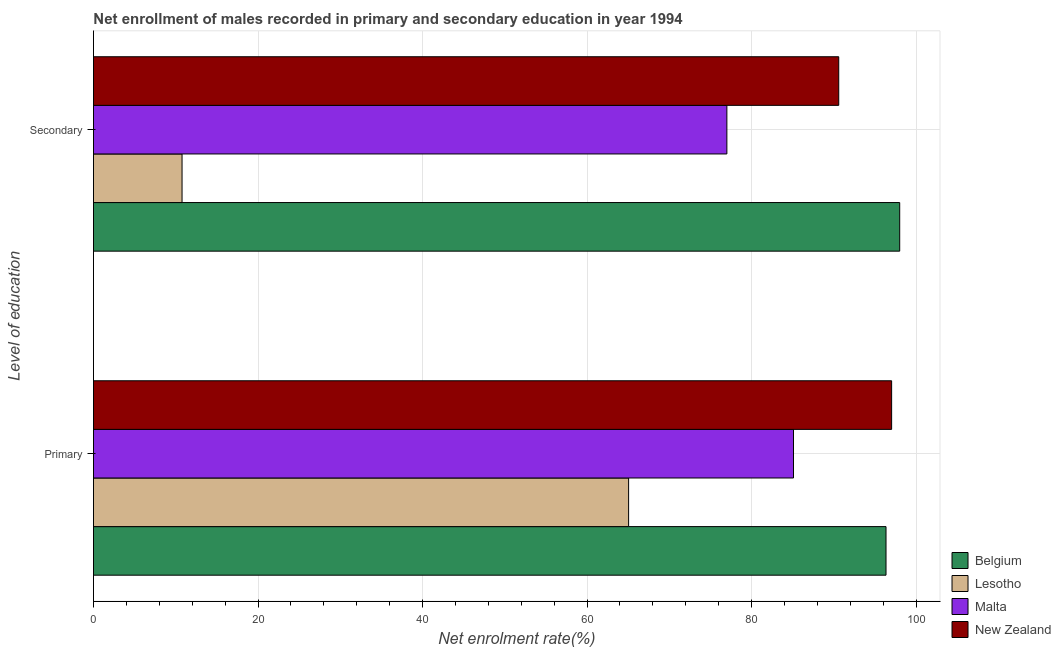How many groups of bars are there?
Offer a very short reply. 2. Are the number of bars on each tick of the Y-axis equal?
Offer a very short reply. Yes. How many bars are there on the 2nd tick from the top?
Your answer should be compact. 4. What is the label of the 1st group of bars from the top?
Ensure brevity in your answer.  Secondary. What is the enrollment rate in primary education in Belgium?
Make the answer very short. 96.34. Across all countries, what is the maximum enrollment rate in primary education?
Provide a short and direct response. 97.02. Across all countries, what is the minimum enrollment rate in primary education?
Provide a succinct answer. 65.05. In which country was the enrollment rate in primary education maximum?
Provide a succinct answer. New Zealand. In which country was the enrollment rate in secondary education minimum?
Your response must be concise. Lesotho. What is the total enrollment rate in primary education in the graph?
Keep it short and to the point. 343.49. What is the difference between the enrollment rate in primary education in Belgium and that in New Zealand?
Provide a succinct answer. -0.68. What is the difference between the enrollment rate in secondary education in Lesotho and the enrollment rate in primary education in Malta?
Provide a short and direct response. -74.32. What is the average enrollment rate in primary education per country?
Provide a succinct answer. 85.87. What is the difference between the enrollment rate in secondary education and enrollment rate in primary education in Belgium?
Provide a succinct answer. 1.66. What is the ratio of the enrollment rate in primary education in Lesotho to that in Malta?
Your answer should be very brief. 0.76. In how many countries, is the enrollment rate in primary education greater than the average enrollment rate in primary education taken over all countries?
Provide a short and direct response. 2. What does the 3rd bar from the top in Secondary represents?
Give a very brief answer. Lesotho. What does the 2nd bar from the bottom in Primary represents?
Your answer should be very brief. Lesotho. How many bars are there?
Offer a terse response. 8. Does the graph contain grids?
Provide a succinct answer. Yes. Where does the legend appear in the graph?
Provide a succinct answer. Bottom right. How are the legend labels stacked?
Provide a succinct answer. Vertical. What is the title of the graph?
Provide a succinct answer. Net enrollment of males recorded in primary and secondary education in year 1994. Does "Malta" appear as one of the legend labels in the graph?
Your answer should be compact. Yes. What is the label or title of the X-axis?
Your answer should be compact. Net enrolment rate(%). What is the label or title of the Y-axis?
Offer a terse response. Level of education. What is the Net enrolment rate(%) of Belgium in Primary?
Your response must be concise. 96.34. What is the Net enrolment rate(%) in Lesotho in Primary?
Your answer should be compact. 65.05. What is the Net enrolment rate(%) in Malta in Primary?
Ensure brevity in your answer.  85.09. What is the Net enrolment rate(%) in New Zealand in Primary?
Provide a short and direct response. 97.02. What is the Net enrolment rate(%) in Belgium in Secondary?
Provide a succinct answer. 98. What is the Net enrolment rate(%) in Lesotho in Secondary?
Give a very brief answer. 10.77. What is the Net enrolment rate(%) in Malta in Secondary?
Give a very brief answer. 76.99. What is the Net enrolment rate(%) of New Zealand in Secondary?
Your answer should be compact. 90.59. Across all Level of education, what is the maximum Net enrolment rate(%) of Belgium?
Ensure brevity in your answer.  98. Across all Level of education, what is the maximum Net enrolment rate(%) in Lesotho?
Your response must be concise. 65.05. Across all Level of education, what is the maximum Net enrolment rate(%) of Malta?
Your answer should be very brief. 85.09. Across all Level of education, what is the maximum Net enrolment rate(%) of New Zealand?
Give a very brief answer. 97.02. Across all Level of education, what is the minimum Net enrolment rate(%) in Belgium?
Offer a terse response. 96.34. Across all Level of education, what is the minimum Net enrolment rate(%) of Lesotho?
Offer a very short reply. 10.77. Across all Level of education, what is the minimum Net enrolment rate(%) in Malta?
Keep it short and to the point. 76.99. Across all Level of education, what is the minimum Net enrolment rate(%) of New Zealand?
Ensure brevity in your answer.  90.59. What is the total Net enrolment rate(%) in Belgium in the graph?
Provide a succinct answer. 194.34. What is the total Net enrolment rate(%) in Lesotho in the graph?
Your response must be concise. 75.81. What is the total Net enrolment rate(%) of Malta in the graph?
Your response must be concise. 162.08. What is the total Net enrolment rate(%) in New Zealand in the graph?
Provide a succinct answer. 187.61. What is the difference between the Net enrolment rate(%) in Belgium in Primary and that in Secondary?
Give a very brief answer. -1.66. What is the difference between the Net enrolment rate(%) of Lesotho in Primary and that in Secondary?
Your answer should be compact. 54.28. What is the difference between the Net enrolment rate(%) in Malta in Primary and that in Secondary?
Provide a succinct answer. 8.1. What is the difference between the Net enrolment rate(%) of New Zealand in Primary and that in Secondary?
Give a very brief answer. 6.43. What is the difference between the Net enrolment rate(%) in Belgium in Primary and the Net enrolment rate(%) in Lesotho in Secondary?
Your answer should be compact. 85.57. What is the difference between the Net enrolment rate(%) in Belgium in Primary and the Net enrolment rate(%) in Malta in Secondary?
Make the answer very short. 19.34. What is the difference between the Net enrolment rate(%) of Belgium in Primary and the Net enrolment rate(%) of New Zealand in Secondary?
Ensure brevity in your answer.  5.75. What is the difference between the Net enrolment rate(%) in Lesotho in Primary and the Net enrolment rate(%) in Malta in Secondary?
Your answer should be compact. -11.94. What is the difference between the Net enrolment rate(%) of Lesotho in Primary and the Net enrolment rate(%) of New Zealand in Secondary?
Keep it short and to the point. -25.54. What is the difference between the Net enrolment rate(%) in Malta in Primary and the Net enrolment rate(%) in New Zealand in Secondary?
Offer a terse response. -5.5. What is the average Net enrolment rate(%) in Belgium per Level of education?
Provide a short and direct response. 97.17. What is the average Net enrolment rate(%) in Lesotho per Level of education?
Your answer should be compact. 37.91. What is the average Net enrolment rate(%) of Malta per Level of education?
Provide a short and direct response. 81.04. What is the average Net enrolment rate(%) of New Zealand per Level of education?
Make the answer very short. 93.8. What is the difference between the Net enrolment rate(%) of Belgium and Net enrolment rate(%) of Lesotho in Primary?
Your response must be concise. 31.29. What is the difference between the Net enrolment rate(%) in Belgium and Net enrolment rate(%) in Malta in Primary?
Give a very brief answer. 11.25. What is the difference between the Net enrolment rate(%) of Belgium and Net enrolment rate(%) of New Zealand in Primary?
Your response must be concise. -0.68. What is the difference between the Net enrolment rate(%) in Lesotho and Net enrolment rate(%) in Malta in Primary?
Make the answer very short. -20.04. What is the difference between the Net enrolment rate(%) in Lesotho and Net enrolment rate(%) in New Zealand in Primary?
Provide a short and direct response. -31.97. What is the difference between the Net enrolment rate(%) of Malta and Net enrolment rate(%) of New Zealand in Primary?
Provide a succinct answer. -11.93. What is the difference between the Net enrolment rate(%) of Belgium and Net enrolment rate(%) of Lesotho in Secondary?
Offer a terse response. 87.23. What is the difference between the Net enrolment rate(%) of Belgium and Net enrolment rate(%) of Malta in Secondary?
Provide a short and direct response. 21.01. What is the difference between the Net enrolment rate(%) in Belgium and Net enrolment rate(%) in New Zealand in Secondary?
Make the answer very short. 7.41. What is the difference between the Net enrolment rate(%) in Lesotho and Net enrolment rate(%) in Malta in Secondary?
Provide a short and direct response. -66.22. What is the difference between the Net enrolment rate(%) in Lesotho and Net enrolment rate(%) in New Zealand in Secondary?
Your response must be concise. -79.82. What is the difference between the Net enrolment rate(%) in Malta and Net enrolment rate(%) in New Zealand in Secondary?
Offer a terse response. -13.6. What is the ratio of the Net enrolment rate(%) in Belgium in Primary to that in Secondary?
Keep it short and to the point. 0.98. What is the ratio of the Net enrolment rate(%) of Lesotho in Primary to that in Secondary?
Keep it short and to the point. 6.04. What is the ratio of the Net enrolment rate(%) of Malta in Primary to that in Secondary?
Provide a short and direct response. 1.11. What is the ratio of the Net enrolment rate(%) in New Zealand in Primary to that in Secondary?
Provide a succinct answer. 1.07. What is the difference between the highest and the second highest Net enrolment rate(%) in Belgium?
Your answer should be compact. 1.66. What is the difference between the highest and the second highest Net enrolment rate(%) in Lesotho?
Provide a succinct answer. 54.28. What is the difference between the highest and the second highest Net enrolment rate(%) in Malta?
Offer a very short reply. 8.1. What is the difference between the highest and the second highest Net enrolment rate(%) of New Zealand?
Offer a very short reply. 6.43. What is the difference between the highest and the lowest Net enrolment rate(%) in Belgium?
Your answer should be compact. 1.66. What is the difference between the highest and the lowest Net enrolment rate(%) in Lesotho?
Your response must be concise. 54.28. What is the difference between the highest and the lowest Net enrolment rate(%) of Malta?
Your response must be concise. 8.1. What is the difference between the highest and the lowest Net enrolment rate(%) in New Zealand?
Provide a short and direct response. 6.43. 